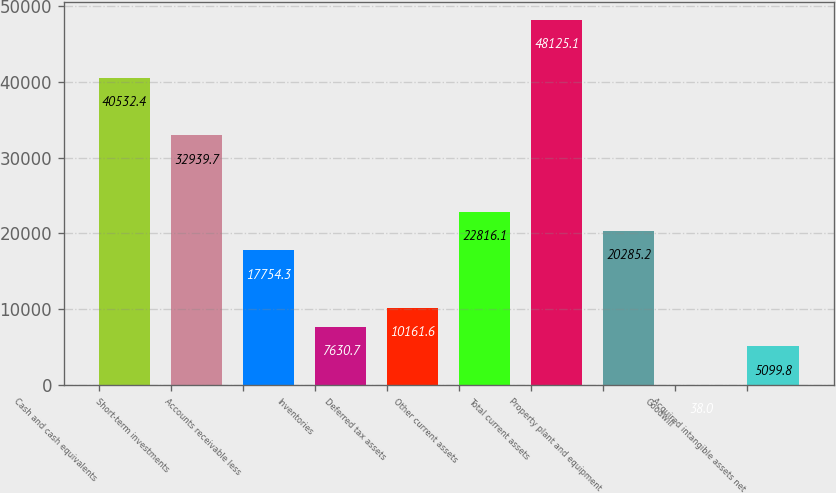Convert chart to OTSL. <chart><loc_0><loc_0><loc_500><loc_500><bar_chart><fcel>Cash and cash equivalents<fcel>Short-term investments<fcel>Accounts receivable less<fcel>Inventories<fcel>Deferred tax assets<fcel>Other current assets<fcel>Total current assets<fcel>Property plant and equipment<fcel>Goodwill<fcel>Acquired intangible assets net<nl><fcel>40532.4<fcel>32939.7<fcel>17754.3<fcel>7630.7<fcel>10161.6<fcel>22816.1<fcel>48125.1<fcel>20285.2<fcel>38<fcel>5099.8<nl></chart> 